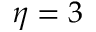<formula> <loc_0><loc_0><loc_500><loc_500>\eta = 3</formula> 